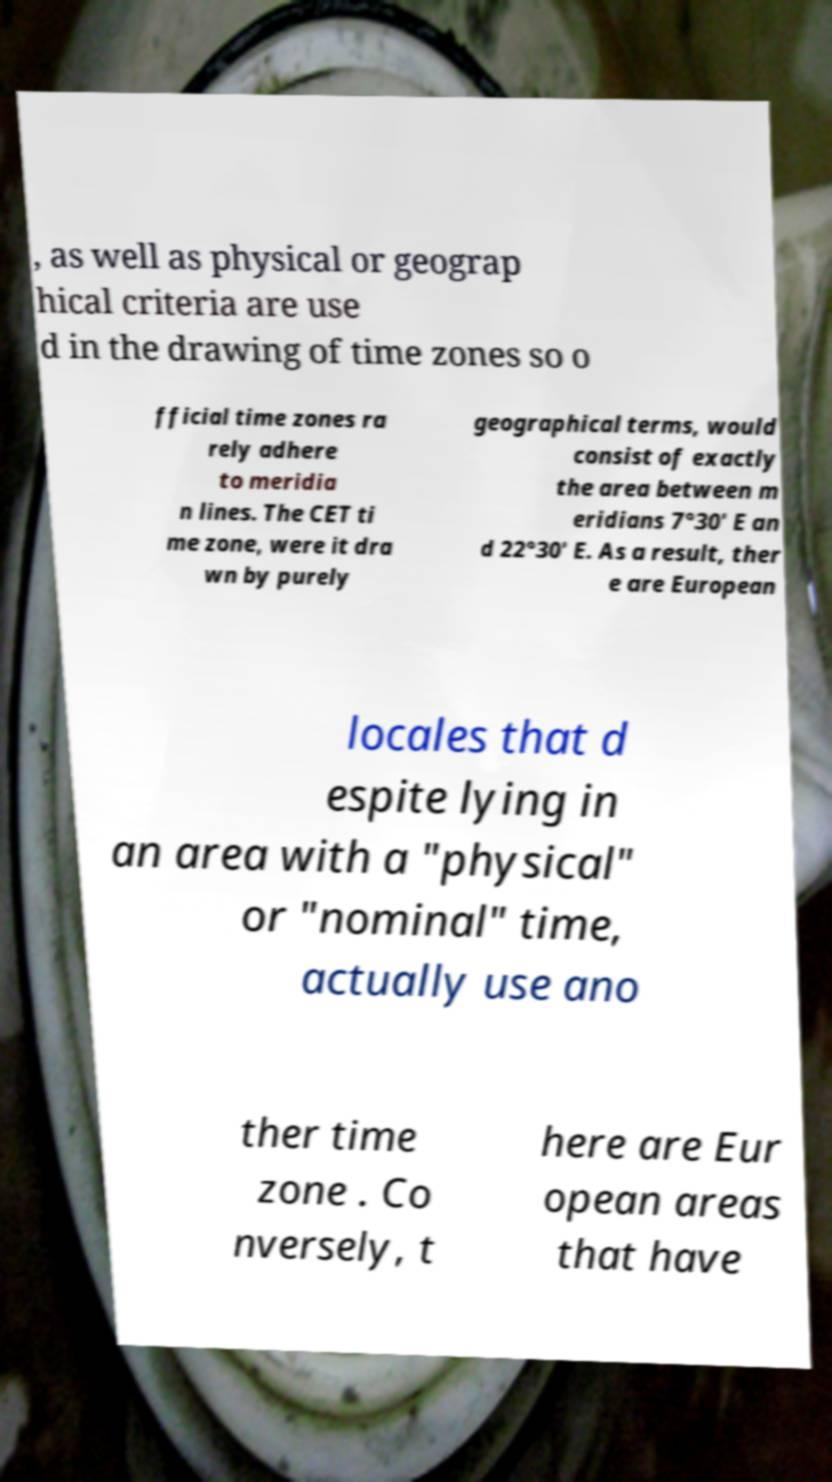I need the written content from this picture converted into text. Can you do that? , as well as physical or geograp hical criteria are use d in the drawing of time zones so o fficial time zones ra rely adhere to meridia n lines. The CET ti me zone, were it dra wn by purely geographical terms, would consist of exactly the area between m eridians 7°30′ E an d 22°30′ E. As a result, ther e are European locales that d espite lying in an area with a "physical" or "nominal" time, actually use ano ther time zone . Co nversely, t here are Eur opean areas that have 